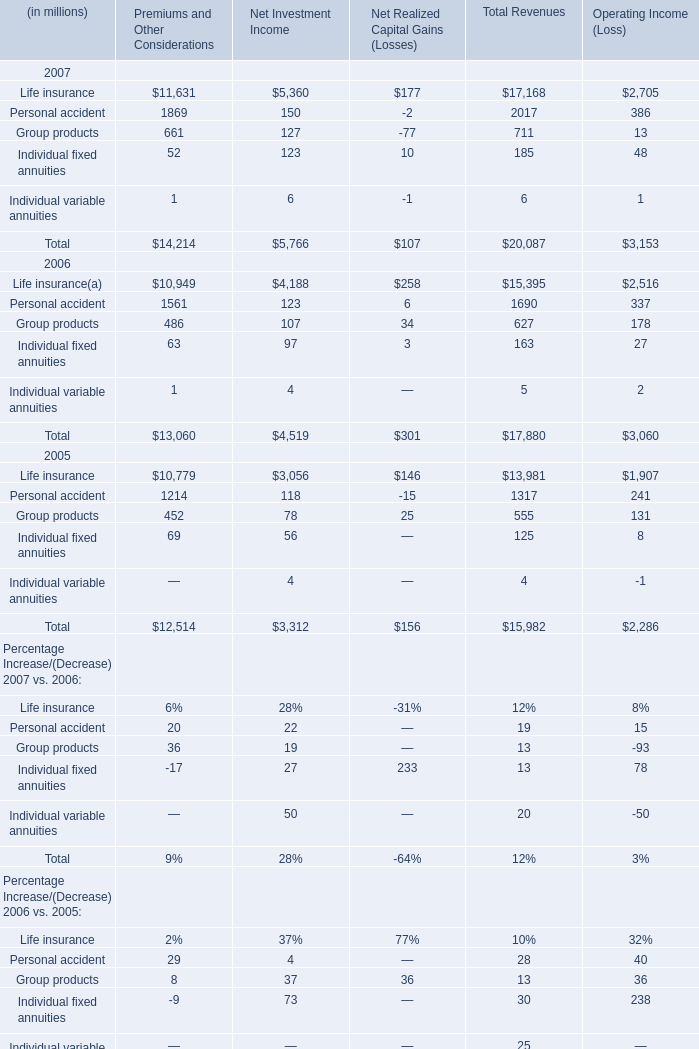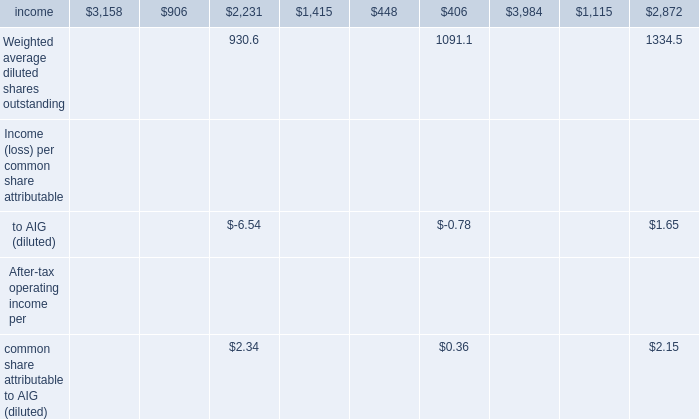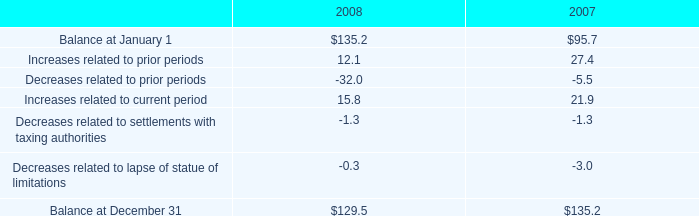what is the percentage change in unrecognized tax benefits between 2007 and 2008? 
Computations: ((129.5 - 135.2) / 135.2)
Answer: -0.04216. 